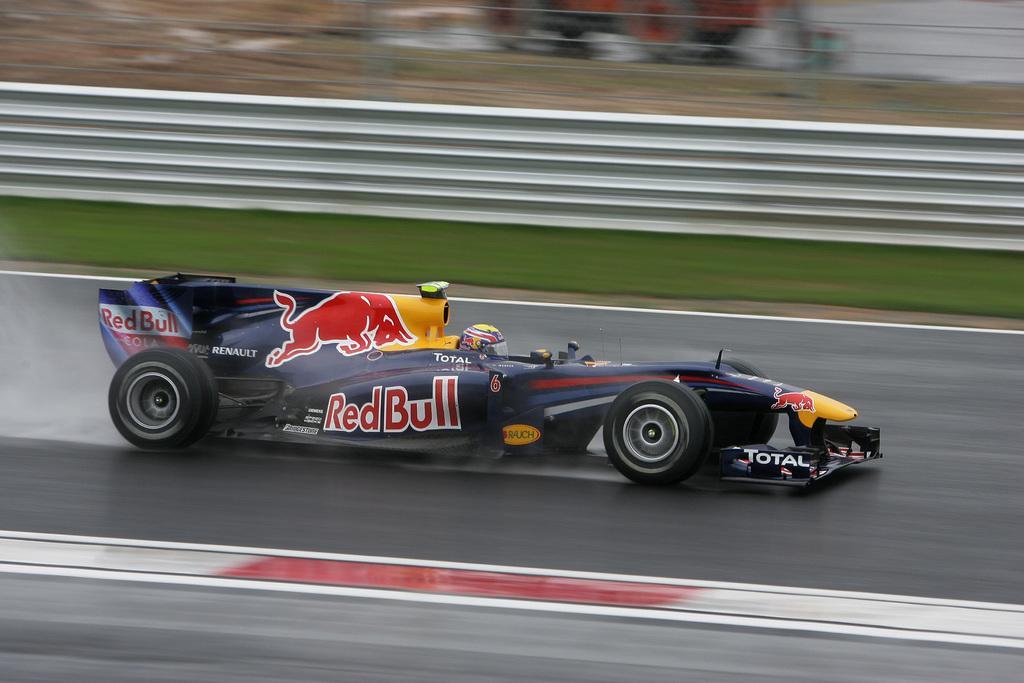Describe this image in one or two sentences. In this image we can see a racing car on the road. In the car we can see a helmet. In the back there is a wall and it is looking blur. 